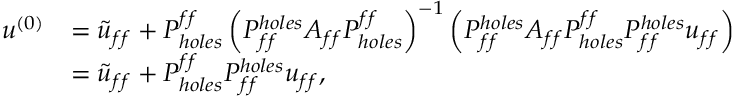<formula> <loc_0><loc_0><loc_500><loc_500>\begin{array} { r l } { u ^ { ( 0 ) } } & { = \tilde { u } _ { f f } + P _ { h o l e s } ^ { f f } \left ( P _ { f f } ^ { h o l e s } A _ { f f } P _ { h o l e s } ^ { f f } \right ) ^ { - 1 } \left ( P _ { f f } ^ { h o l e s } A _ { f f } P _ { h o l e s } ^ { f f } P _ { f f } ^ { h o l e s } u _ { f f } \right ) } \\ & { = \tilde { u } _ { f f } + P _ { h o l e s } ^ { f f } P _ { f f } ^ { h o l e s } u _ { f f } , } \end{array}</formula> 